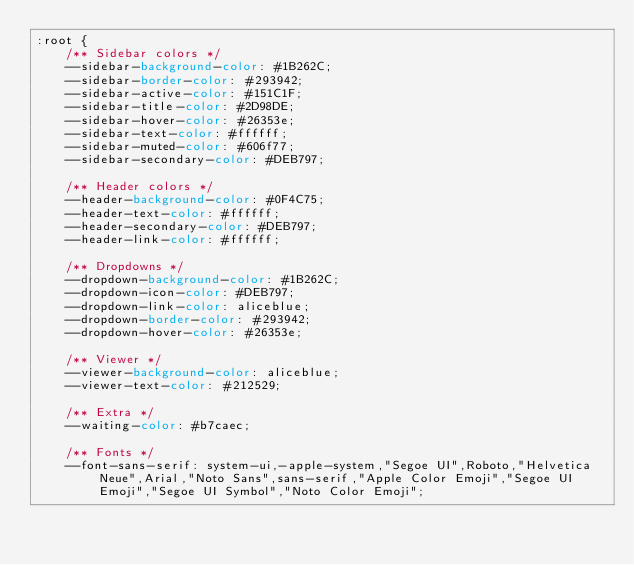Convert code to text. <code><loc_0><loc_0><loc_500><loc_500><_CSS_>:root {
    /** Sidebar colors */
    --sidebar-background-color: #1B262C;
    --sidebar-border-color: #293942;
    --sidebar-active-color: #151C1F;
    --sidebar-title-color: #2D98DE;
    --sidebar-hover-color: #26353e;
    --sidebar-text-color: #ffffff;
    --sidebar-muted-color: #606f77;
    --sidebar-secondary-color: #DEB797;
    
    /** Header colors */
    --header-background-color: #0F4C75;
    --header-text-color: #ffffff;
    --header-secondary-color: #DEB797;
    --header-link-color: #ffffff;

    /** Dropdowns */
    --dropdown-background-color: #1B262C;
    --dropdown-icon-color: #DEB797;
    --dropdown-link-color: aliceblue;
    --dropdown-border-color: #293942;
    --dropdown-hover-color: #26353e;

    /** Viewer */
    --viewer-background-color: aliceblue;
    --viewer-text-color: #212529;

    /** Extra */
    --waiting-color: #b7caec;

    /** Fonts */
    --font-sans-serif: system-ui,-apple-system,"Segoe UI",Roboto,"Helvetica Neue",Arial,"Noto Sans",sans-serif,"Apple Color Emoji","Segoe UI Emoji","Segoe UI Symbol","Noto Color Emoji";</code> 